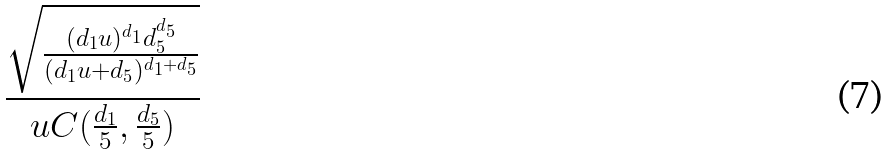Convert formula to latex. <formula><loc_0><loc_0><loc_500><loc_500>\frac { \sqrt { \frac { ( d _ { 1 } u ) ^ { d _ { 1 } } d _ { 5 } ^ { d _ { 5 } } } { ( d _ { 1 } u + d _ { 5 } ) ^ { d _ { 1 } + d _ { 5 } } } } } { u C ( \frac { d _ { 1 } } { 5 } , \frac { d _ { 5 } } { 5 } ) }</formula> 